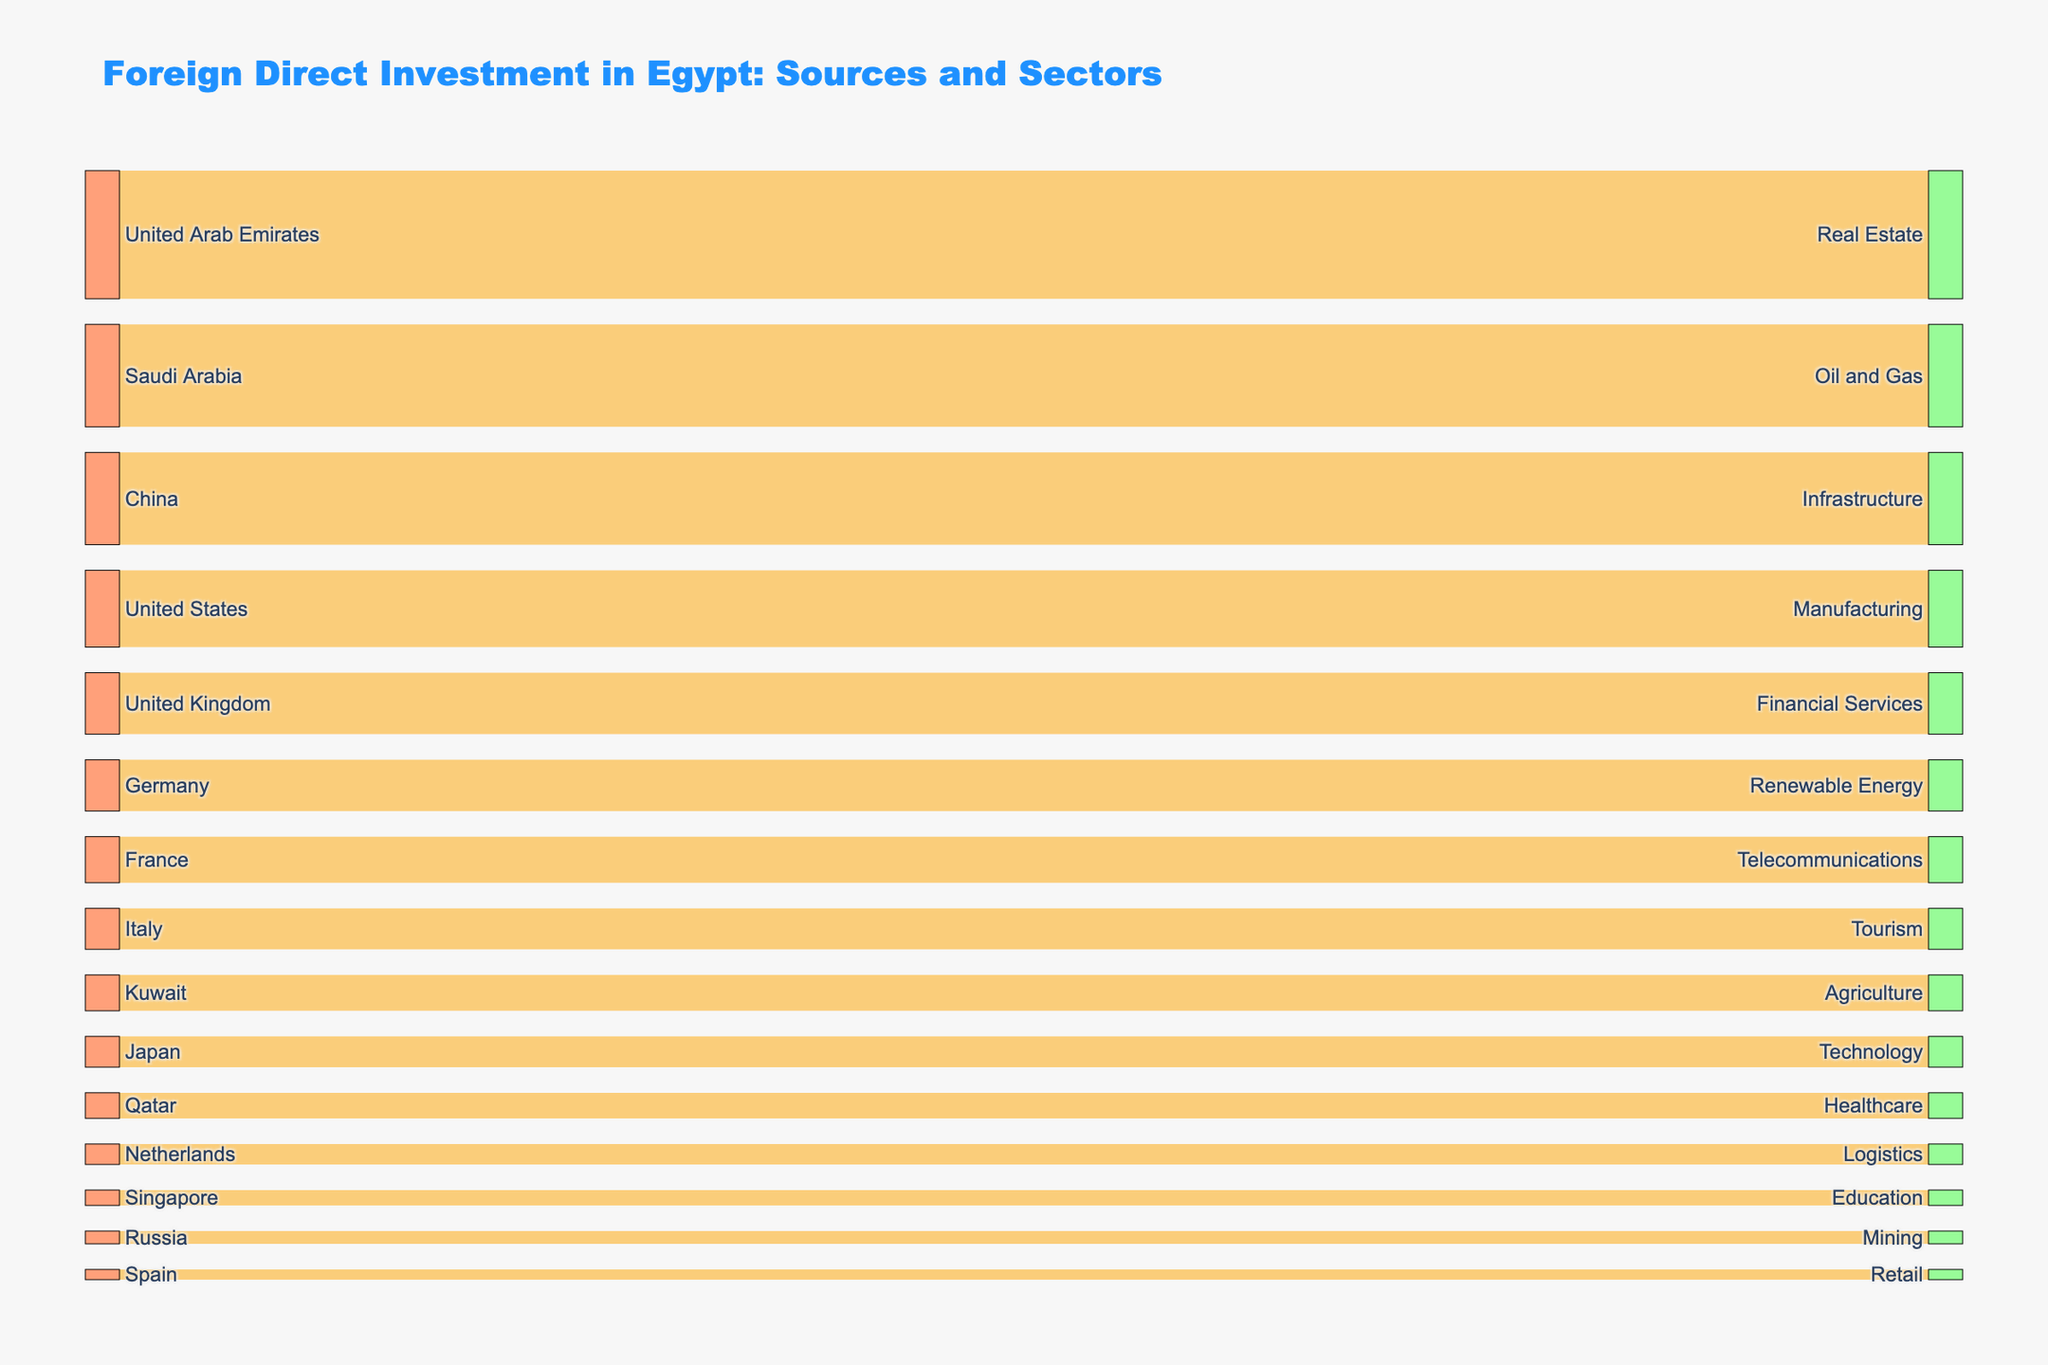What is the sector that received the largest amount of FDI from a single source? The largest amount from a single source can be identified by visually checking the width of the flows in the Sankey diagram. The widest flow indicates the largest amount. According to the data, the United Arab Emirates invested the most in Real Estate, with an amount of 2500.
Answer: Real Estate How much FDI did the Oil and Gas sector receive and which source contributed to it? From the Sankey diagram, we can see the flow connecting to the Oil and Gas sector. In this case, the investment amount is labeled, and it's 2000, coming from Saudi Arabia.
Answer: 2000, Saudi Arabia Which country has invested the most in Egypt, and into which sector? To determine the largest investor, check the width of each flow originating from the different sources. The widest flow originates from the United Arab Emirates, investing 2500 in the Real Estate sector.
Answer: United Arab Emirates, Real Estate Is the combined FDI in the Oil and Gas and Renewable Energy sectors more than the total FDI from the United States? First, sum the FDI amounts in the Oil and Gas and Renewable Energy sectors: 2000 (Oil and Gas) + 1000 (Renewable Energy) = 3000. Now compare this with the FDI from the United States, which is 1500. Since 3000 is greater than 1500, the combined FDI in these sectors is more.
Answer: Yes How much more did the largest sector receive compared to the smallest sector in this dataset? Identify the largest and smallest sectors by their investment amounts. The largest sector is Real Estate with 2500, and the smallest sector is Retail with 200. The difference is 2500 - 200 = 2300.
Answer: 2300 What is the total FDI from all sources into the Healthcare and Education sectors combined? Sum the amounts of FDI from the figure that flow into the Healthcare and Education sectors. According to the figure, Healthcare received 500 and Education received 300. The total is 500 + 300 = 800.
Answer: 800 Which sector received investment from more than one source? Review the connections in the Sankey diagram to see if any sectors have multiple incoming flows. In this dataset, all sectors received investment from only a single source.
Answer: None 